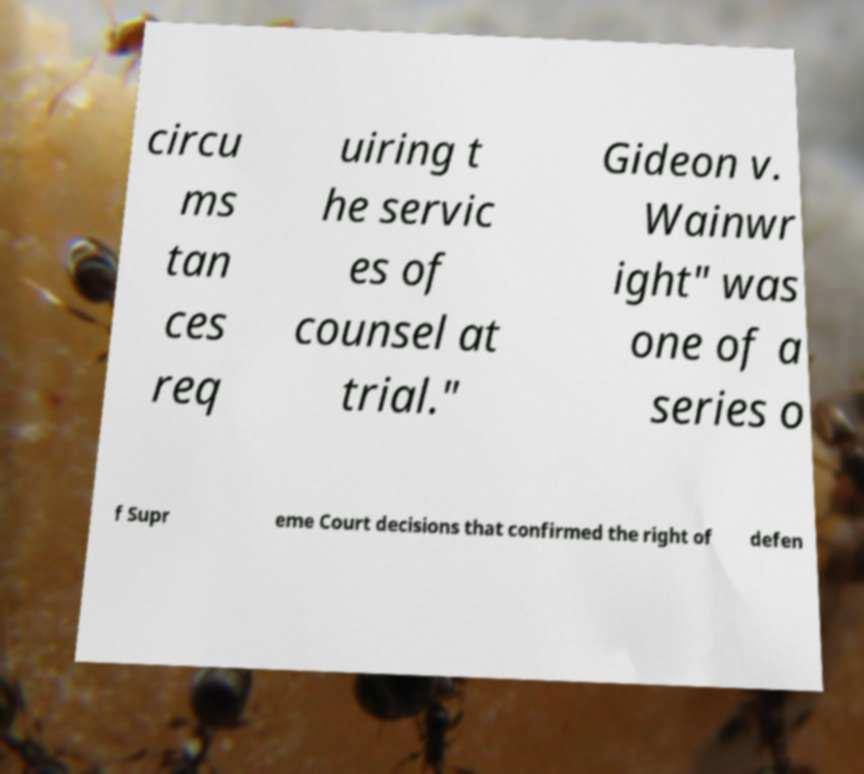Can you accurately transcribe the text from the provided image for me? circu ms tan ces req uiring t he servic es of counsel at trial." Gideon v. Wainwr ight" was one of a series o f Supr eme Court decisions that confirmed the right of defen 